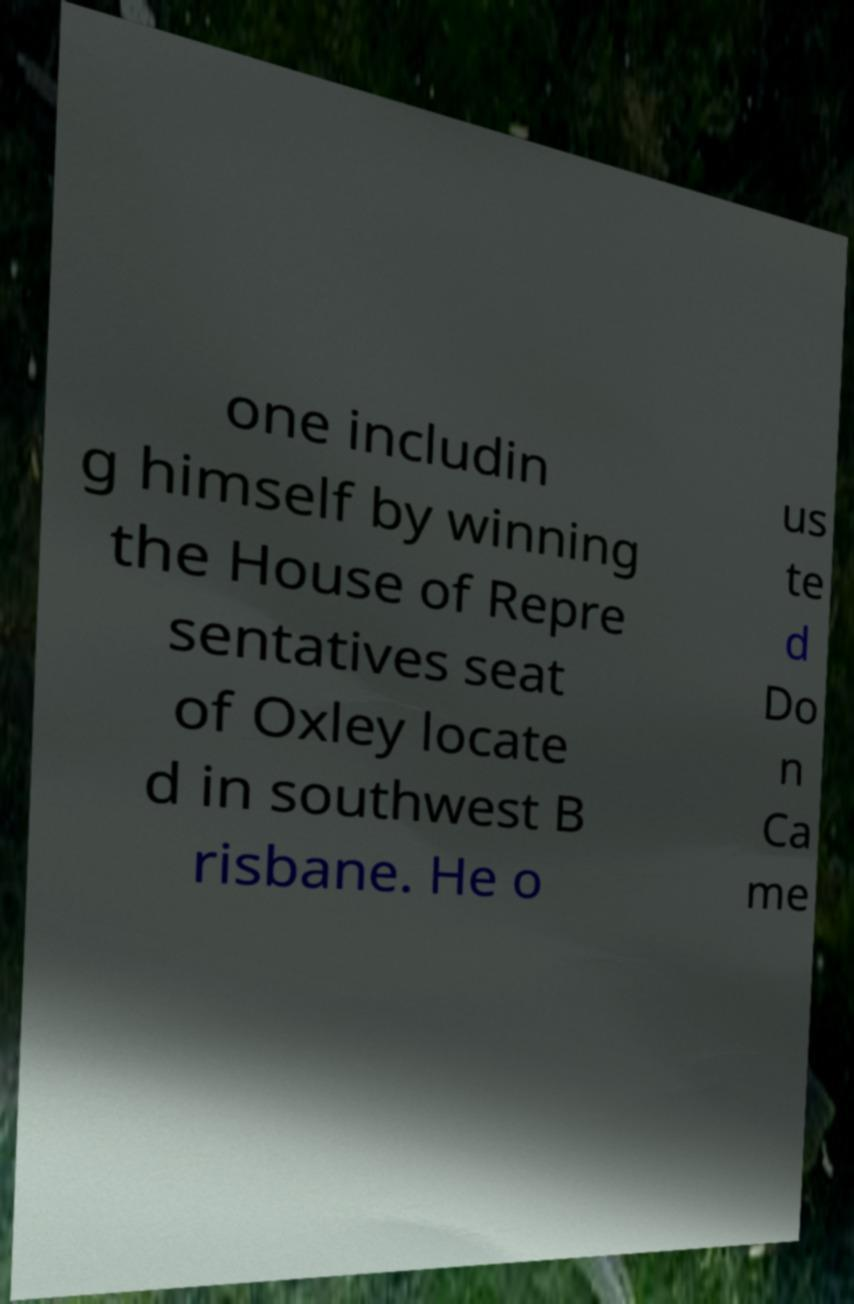Please identify and transcribe the text found in this image. one includin g himself by winning the House of Repre sentatives seat of Oxley locate d in southwest B risbane. He o us te d Do n Ca me 